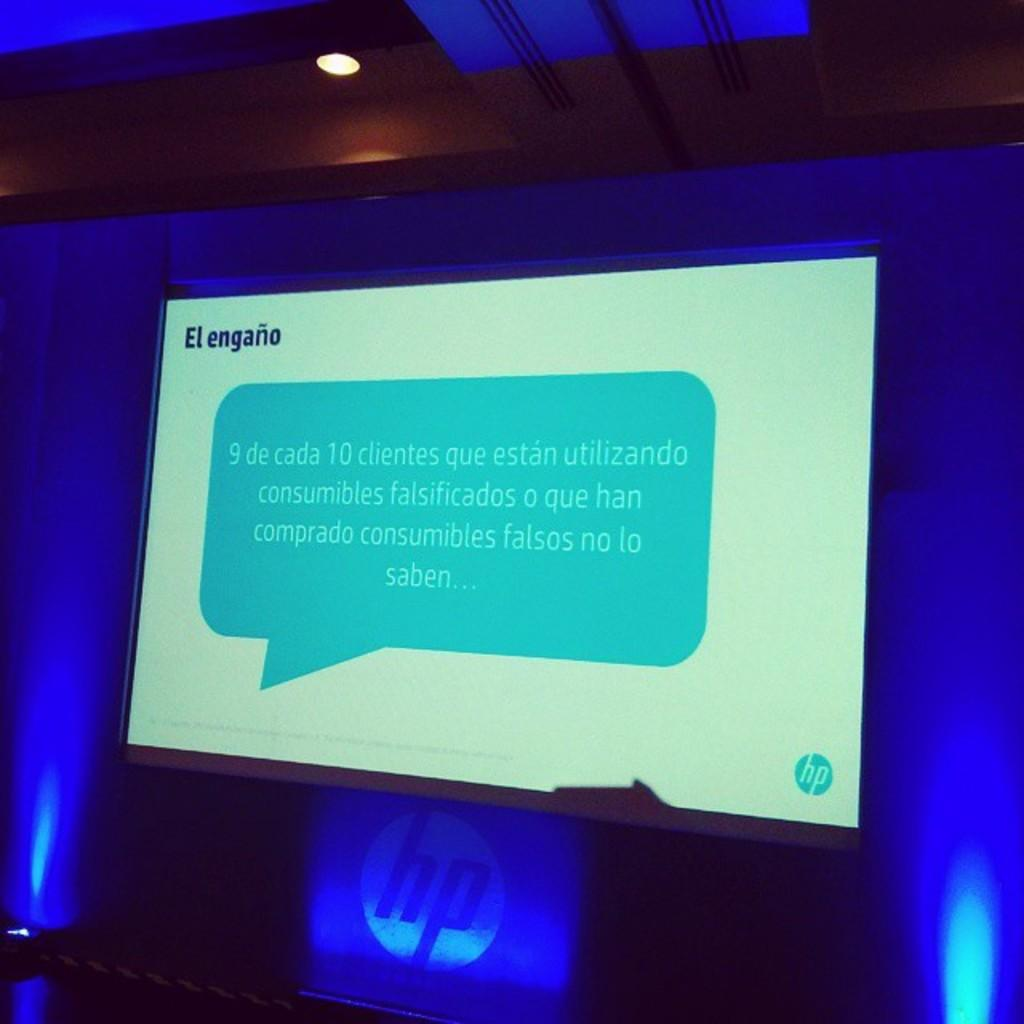<image>
Summarize the visual content of the image. Text written in Spanish is displayed on a HP monitor. 